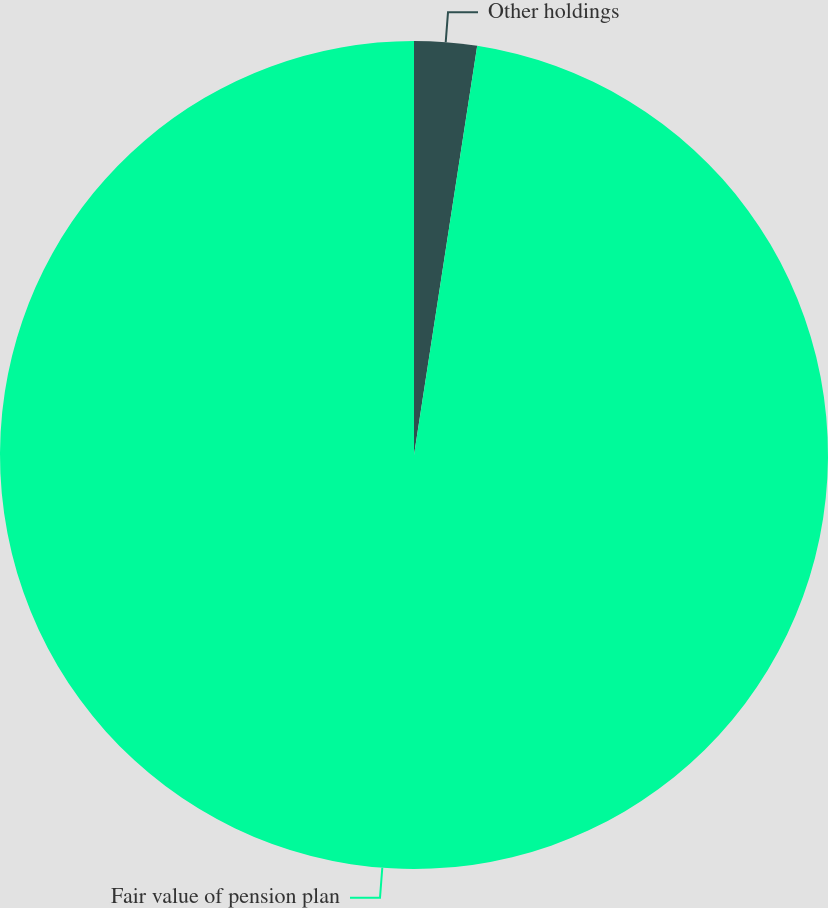Convert chart to OTSL. <chart><loc_0><loc_0><loc_500><loc_500><pie_chart><fcel>Other holdings<fcel>Fair value of pension plan<nl><fcel>2.44%<fcel>97.56%<nl></chart> 